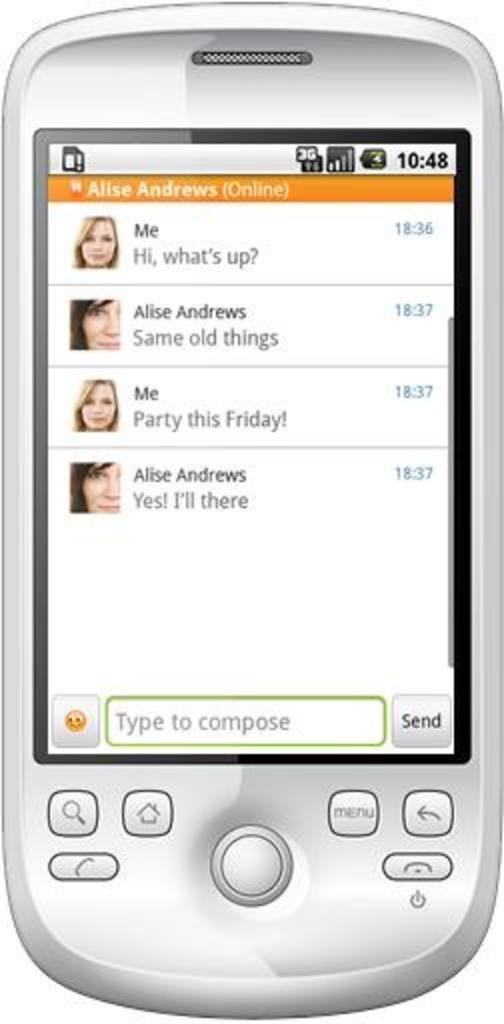<image>
Summarize the visual content of the image. A phone displaying text messages about a party on the screen. 